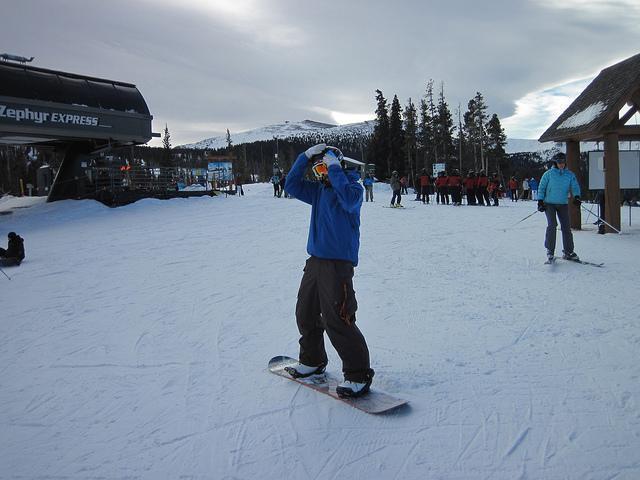What do these men plan to do here?
Indicate the correct response and explain using: 'Answer: answer
Rationale: rationale.'
Options: Ski, hike, run, swim. Answer: ski.
Rationale: This is a ski resort and that's one of the things people come up here to do. 